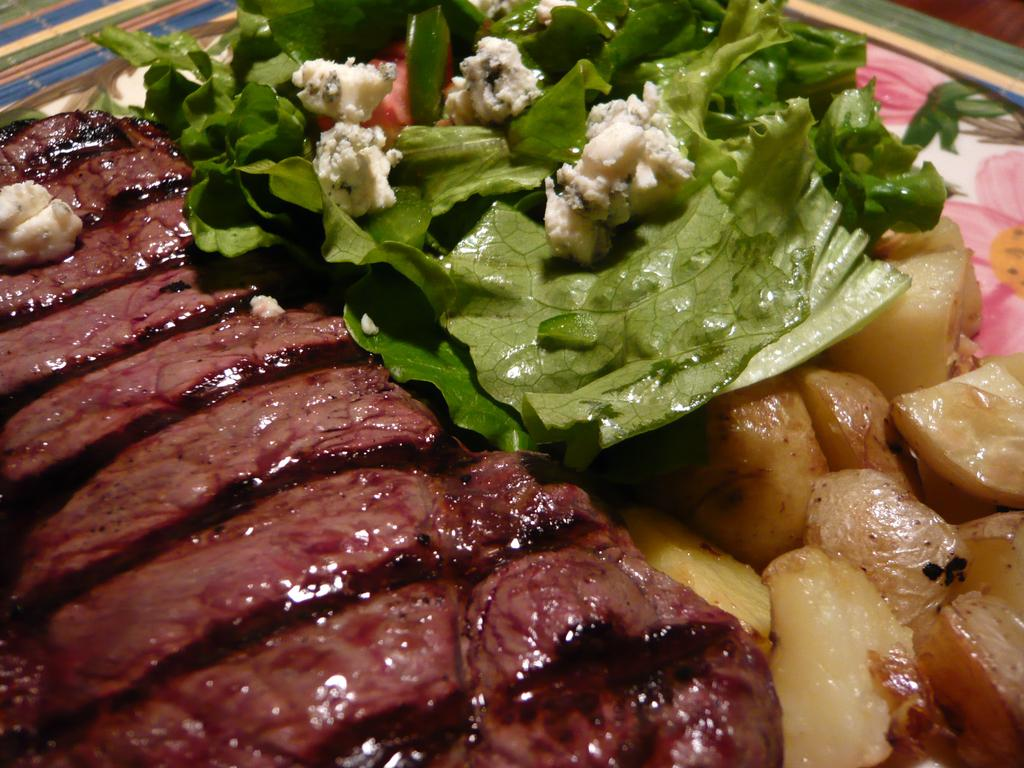What type of food can be seen in the image? There is food in the image, but the specific type is not mentioned. What is placed on the plate in the image? There are leaves on a plate in the image. On what surface is the plate placed? The plate is placed on a surface. How fast is the rate of the earthquake in the image? There is no earthquake present in the image, so it is not possible to determine the rate of an earthquake. 